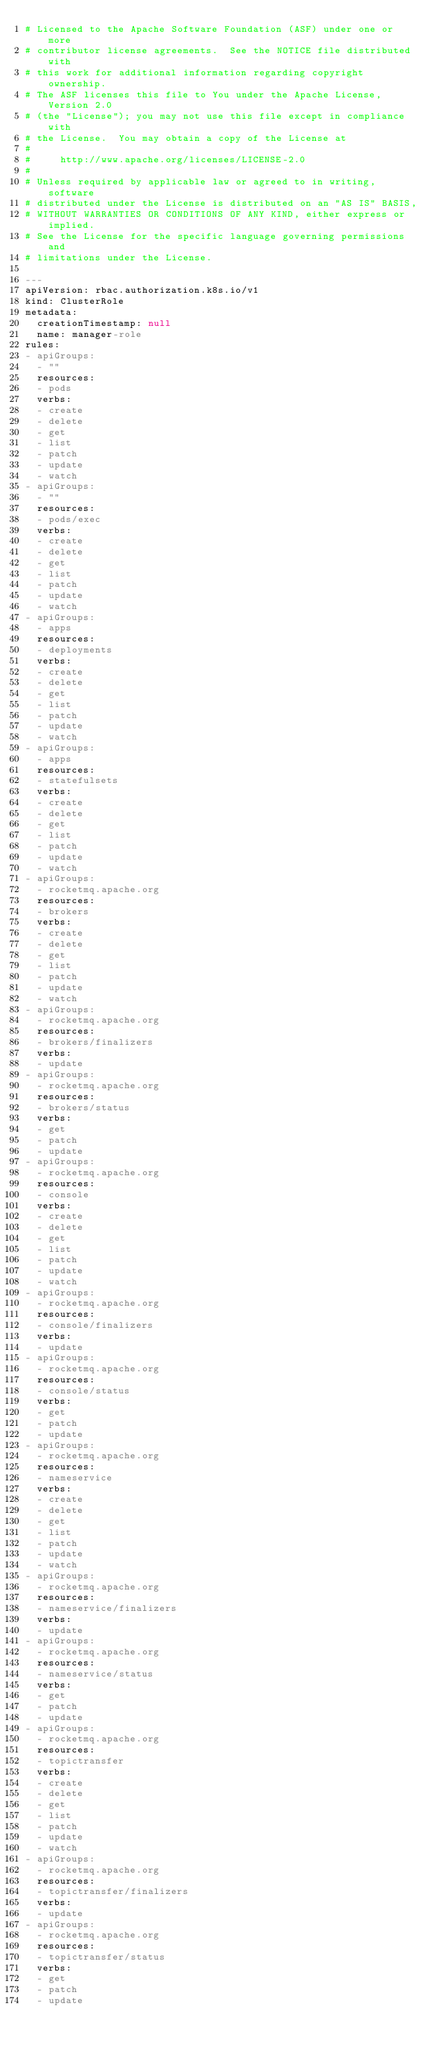<code> <loc_0><loc_0><loc_500><loc_500><_YAML_># Licensed to the Apache Software Foundation (ASF) under one or more
# contributor license agreements.  See the NOTICE file distributed with
# this work for additional information regarding copyright ownership.
# The ASF licenses this file to You under the Apache License, Version 2.0
# (the "License"); you may not use this file except in compliance with
# the License.  You may obtain a copy of the License at
#
#     http://www.apache.org/licenses/LICENSE-2.0
#
# Unless required by applicable law or agreed to in writing, software
# distributed under the License is distributed on an "AS IS" BASIS,
# WITHOUT WARRANTIES OR CONDITIONS OF ANY KIND, either express or implied.
# See the License for the specific language governing permissions and
# limitations under the License.

---
apiVersion: rbac.authorization.k8s.io/v1
kind: ClusterRole
metadata:
  creationTimestamp: null
  name: manager-role
rules:
- apiGroups:
  - ""
  resources:
  - pods
  verbs:
  - create
  - delete
  - get
  - list
  - patch
  - update
  - watch
- apiGroups:
  - ""
  resources:
  - pods/exec
  verbs:
  - create
  - delete
  - get
  - list
  - patch
  - update
  - watch
- apiGroups:
  - apps
  resources:
  - deployments
  verbs:
  - create
  - delete
  - get
  - list
  - patch
  - update
  - watch
- apiGroups:
  - apps
  resources:
  - statefulsets
  verbs:
  - create
  - delete
  - get
  - list
  - patch
  - update
  - watch
- apiGroups:
  - rocketmq.apache.org
  resources:
  - brokers
  verbs:
  - create
  - delete
  - get
  - list
  - patch
  - update
  - watch
- apiGroups:
  - rocketmq.apache.org
  resources:
  - brokers/finalizers
  verbs:
  - update
- apiGroups:
  - rocketmq.apache.org
  resources:
  - brokers/status
  verbs:
  - get
  - patch
  - update
- apiGroups:
  - rocketmq.apache.org
  resources:
  - console
  verbs:
  - create
  - delete
  - get
  - list
  - patch
  - update
  - watch
- apiGroups:
  - rocketmq.apache.org
  resources:
  - console/finalizers
  verbs:
  - update
- apiGroups:
  - rocketmq.apache.org
  resources:
  - console/status
  verbs:
  - get
  - patch
  - update
- apiGroups:
  - rocketmq.apache.org
  resources:
  - nameservice
  verbs:
  - create
  - delete
  - get
  - list
  - patch
  - update
  - watch
- apiGroups:
  - rocketmq.apache.org
  resources:
  - nameservice/finalizers
  verbs:
  - update
- apiGroups:
  - rocketmq.apache.org
  resources:
  - nameservice/status
  verbs:
  - get
  - patch
  - update
- apiGroups:
  - rocketmq.apache.org
  resources:
  - topictransfer
  verbs:
  - create
  - delete
  - get
  - list
  - patch
  - update
  - watch
- apiGroups:
  - rocketmq.apache.org
  resources:
  - topictransfer/finalizers
  verbs:
  - update
- apiGroups:
  - rocketmq.apache.org
  resources:
  - topictransfer/status
  verbs:
  - get
  - patch
  - update
</code> 